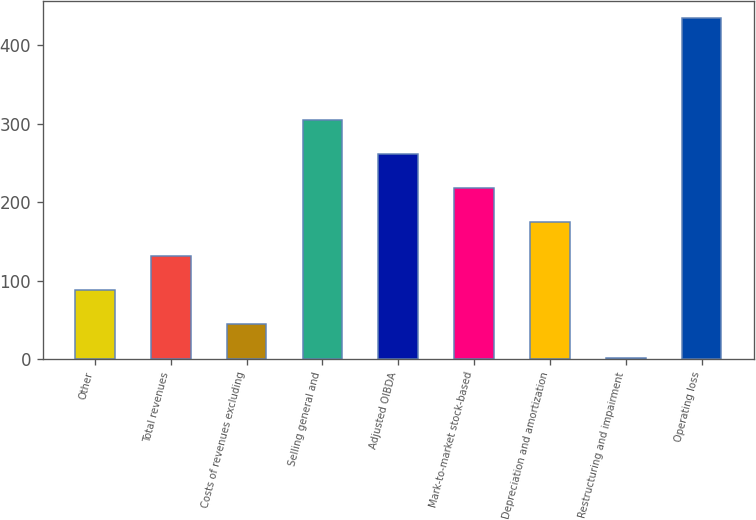Convert chart. <chart><loc_0><loc_0><loc_500><loc_500><bar_chart><fcel>Other<fcel>Total revenues<fcel>Costs of revenues excluding<fcel>Selling general and<fcel>Adjusted OIBDA<fcel>Mark-to-market stock-based<fcel>Depreciation and amortization<fcel>Restructuring and impairment<fcel>Operating loss<nl><fcel>88.4<fcel>131.6<fcel>45.2<fcel>304.4<fcel>261.2<fcel>218<fcel>174.8<fcel>2<fcel>434<nl></chart> 